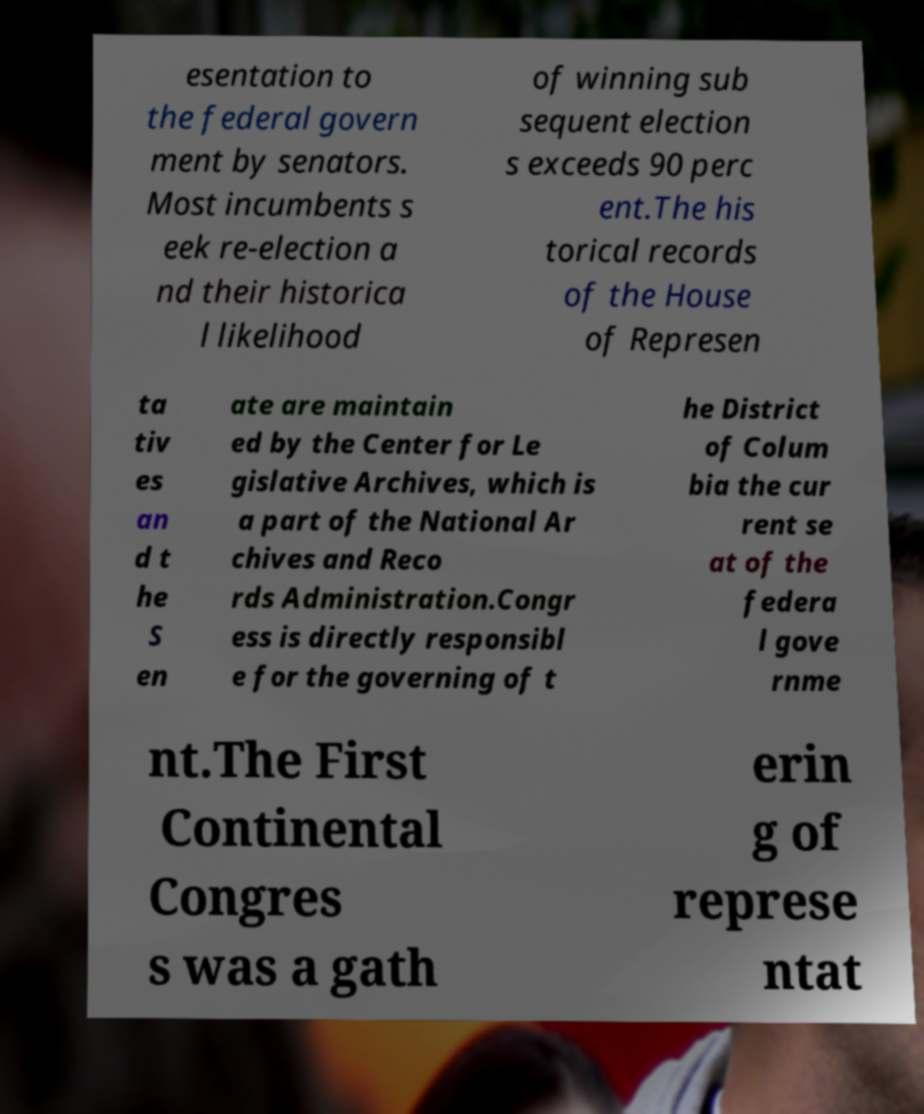Could you assist in decoding the text presented in this image and type it out clearly? esentation to the federal govern ment by senators. Most incumbents s eek re-election a nd their historica l likelihood of winning sub sequent election s exceeds 90 perc ent.The his torical records of the House of Represen ta tiv es an d t he S en ate are maintain ed by the Center for Le gislative Archives, which is a part of the National Ar chives and Reco rds Administration.Congr ess is directly responsibl e for the governing of t he District of Colum bia the cur rent se at of the federa l gove rnme nt.The First Continental Congres s was a gath erin g of represe ntat 